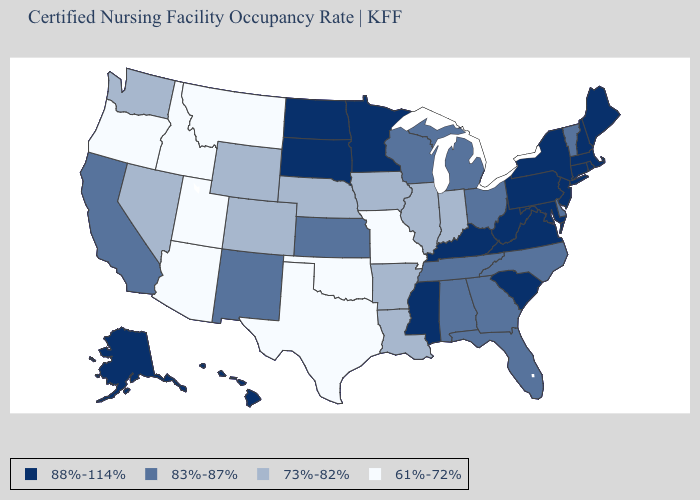What is the value of Indiana?
Short answer required. 73%-82%. Which states have the lowest value in the Northeast?
Write a very short answer. Vermont. What is the value of Delaware?
Be succinct. 83%-87%. Does the first symbol in the legend represent the smallest category?
Concise answer only. No. Which states have the lowest value in the South?
Concise answer only. Oklahoma, Texas. Among the states that border Missouri , does Kansas have the highest value?
Quick response, please. No. Does the first symbol in the legend represent the smallest category?
Give a very brief answer. No. What is the value of Rhode Island?
Answer briefly. 88%-114%. Does Maryland have the highest value in the South?
Concise answer only. Yes. What is the value of Utah?
Answer briefly. 61%-72%. Does Colorado have the same value as Arizona?
Short answer required. No. How many symbols are there in the legend?
Write a very short answer. 4. Does Virginia have the lowest value in the South?
Be succinct. No. Does Arizona have the lowest value in the West?
Quick response, please. Yes. Does Arkansas have the lowest value in the USA?
Keep it brief. No. 